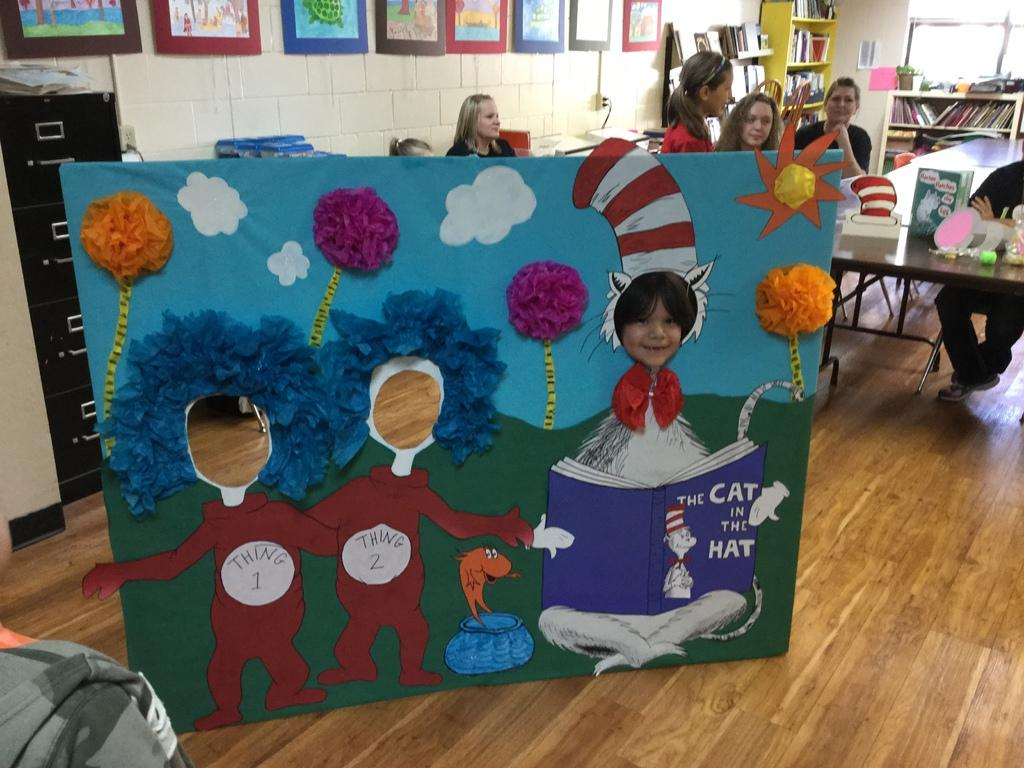<image>
Present a compact description of the photo's key features. A Cat in the Hat and Thing one and Thing two face cut out board for children. 